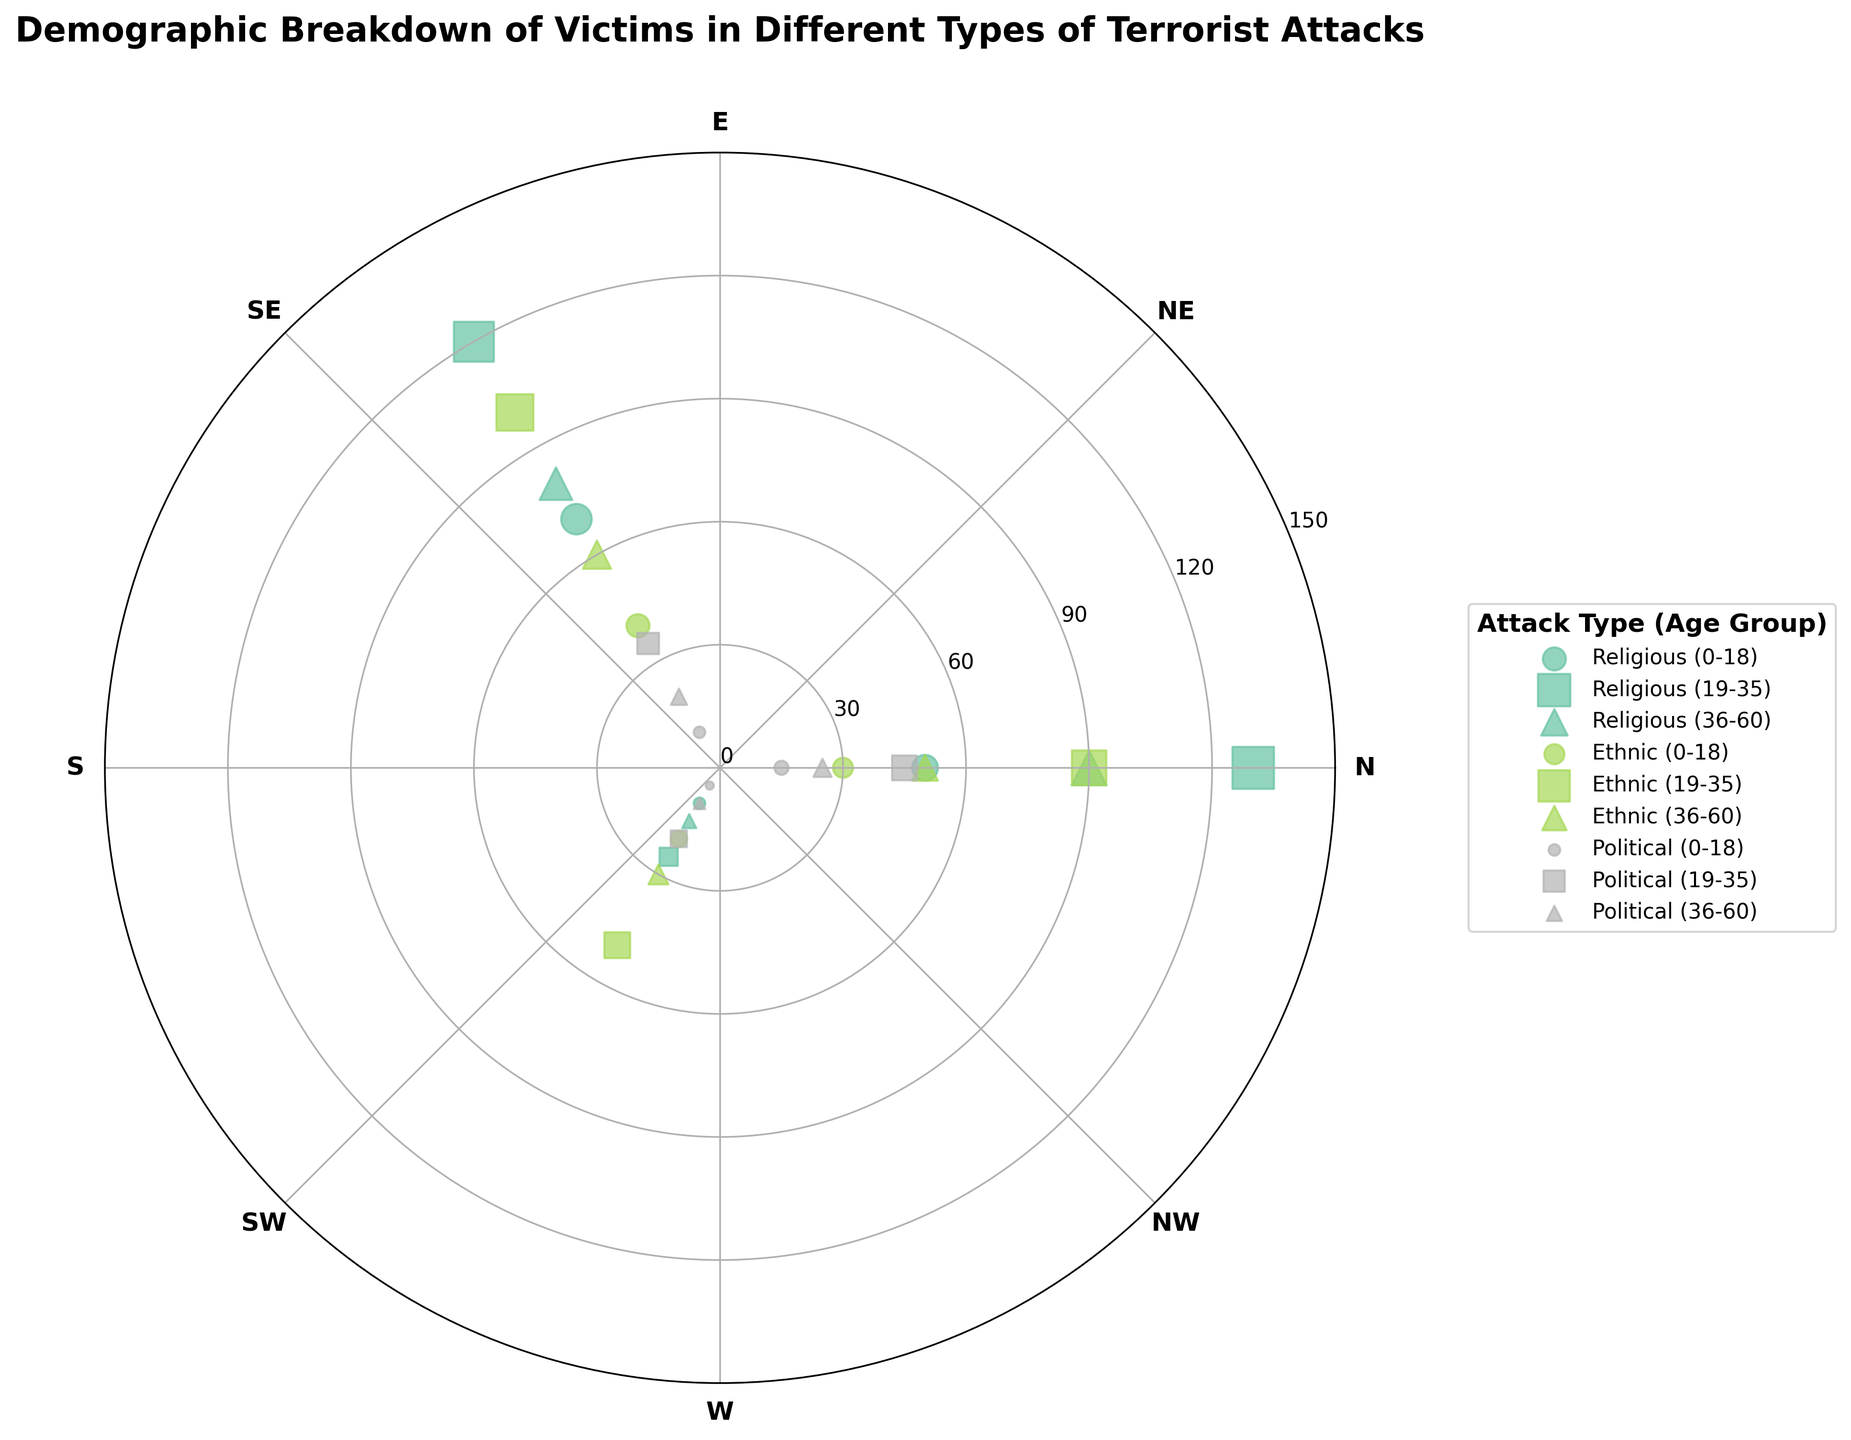What is the title of the figure? The title is usually displayed in a prominent position, often at the top of the figure. In this case, it is displayed above the polar scatter chart.
Answer: Demographic Breakdown of Victims in Different Types of Terrorist Attacks Which type of attack has the highest victim count for the age group 19-35? Look for the color and marker indicating the age group 19-35 for each type of attack. Compare the distances from the center, as a longer distance means a higher count. Religious attacks (red color and circle marker) have the furthest points from the center for this age group.
Answer: Religious How many total victims are there in the age group 0-18 across all attack types? Sum the counts for the age group 0-18 across all attack types by identifying the respective colors and marker types for each group and adding the counts.
Answer: 240 What is the average number of victims among Jews across all age groups in religious attacks? To find this, sum up the number of victims in the Jewish group for each age category (10 + 25 + 15 = 50), then divide by the number of categories (3) to get the average.
Answer: 16.67 Which age group has the lower count of environmentalist victims, 0-18 or 36-60? Compare the radial distances of the 0-18 and 36-60 age groups for environmentalist victims, indicated by respective markers and positions on the chart.
Answer: 36-60 Within ethnic attacks, which group has the highest representation in the 19-35 category? Identify the ethnic groups in the 19-35 age range and compare the distances from the center for each group. Latinos (yellow color, square marker) have the highest value.
Answer: Latinos What is the difference in victim count between Christians and Muslims in the 0-18 age group for religious attacks? Find the radial distance (count) for Christians (50) and Muslims (70) in the 0-18 category and calculate the difference (70 - 50).
Answer: 20 Comparing right-wing and left-wing activists, which group has fewer victims in the age group 0-18 in political attacks? Observe the radial distances for the markers representing right-wing and left-wing activists in the 0-18 age range. Left-wing activists (blue color, circle marker) have a shorter distance from the center.
Answer: Left-wing activists What is the most common age group affected by religious attacks? Compare the victim counts for Christians, Muslims, and Jews among different age groups and find the age group with the highest total count. The age group 19-35 appears to have the highest counts across these religious groups.
Answer: 19-35 